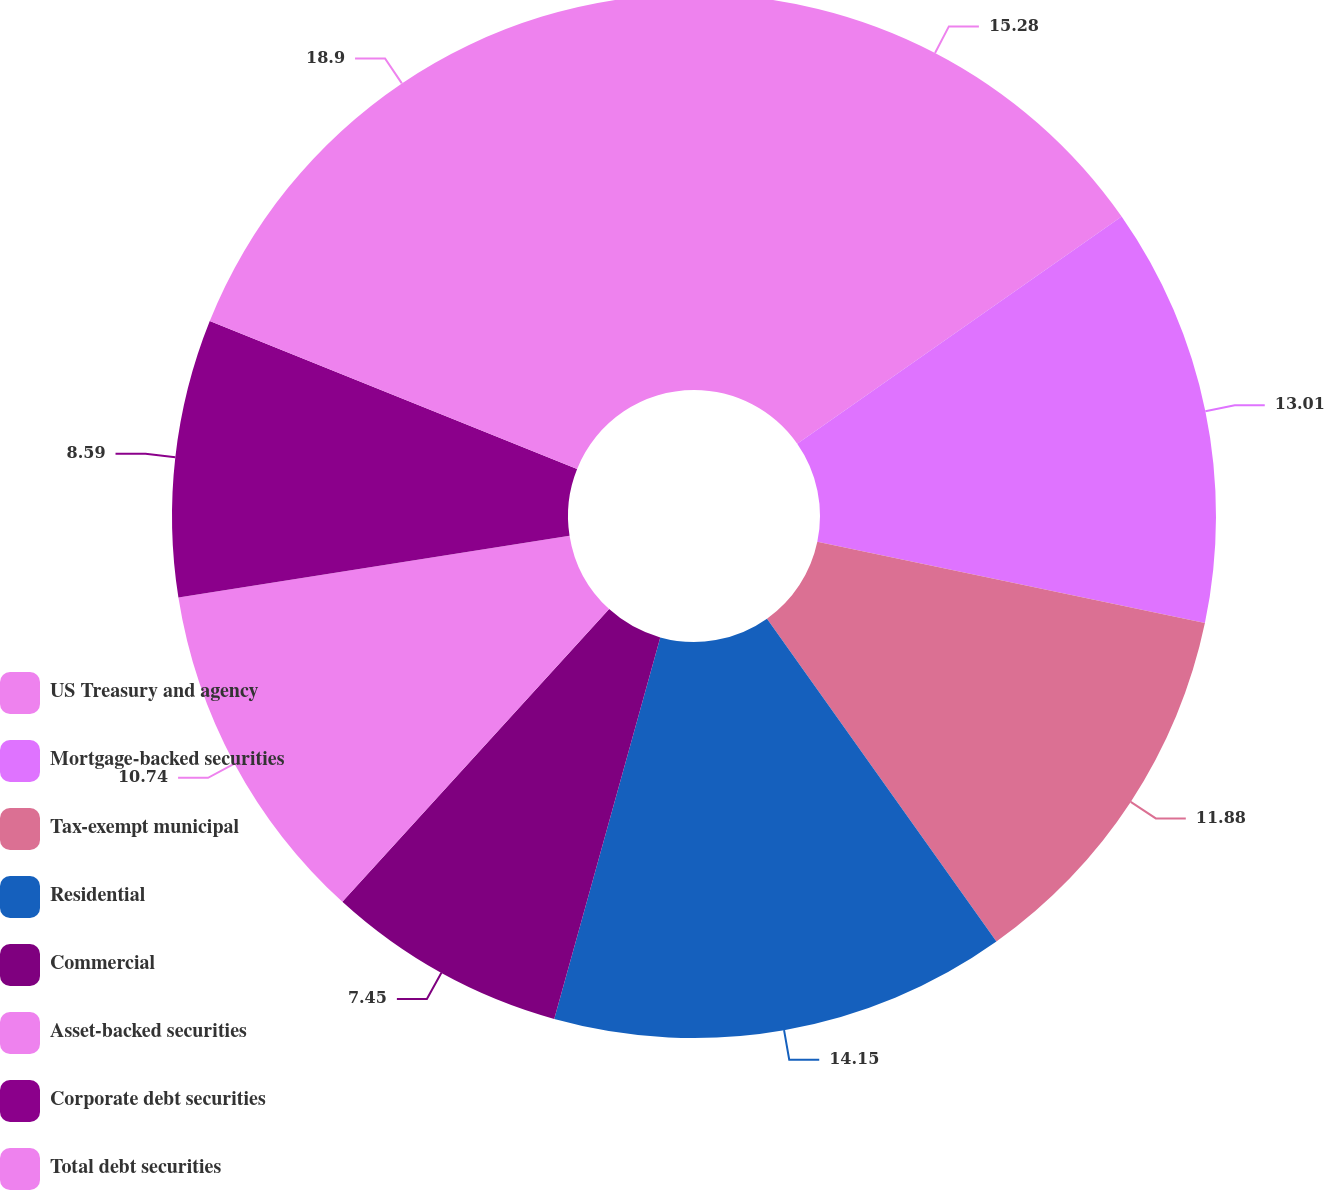<chart> <loc_0><loc_0><loc_500><loc_500><pie_chart><fcel>US Treasury and agency<fcel>Mortgage-backed securities<fcel>Tax-exempt municipal<fcel>Residential<fcel>Commercial<fcel>Asset-backed securities<fcel>Corporate debt securities<fcel>Total debt securities<nl><fcel>15.28%<fcel>13.01%<fcel>11.88%<fcel>14.15%<fcel>7.45%<fcel>10.74%<fcel>8.59%<fcel>18.91%<nl></chart> 